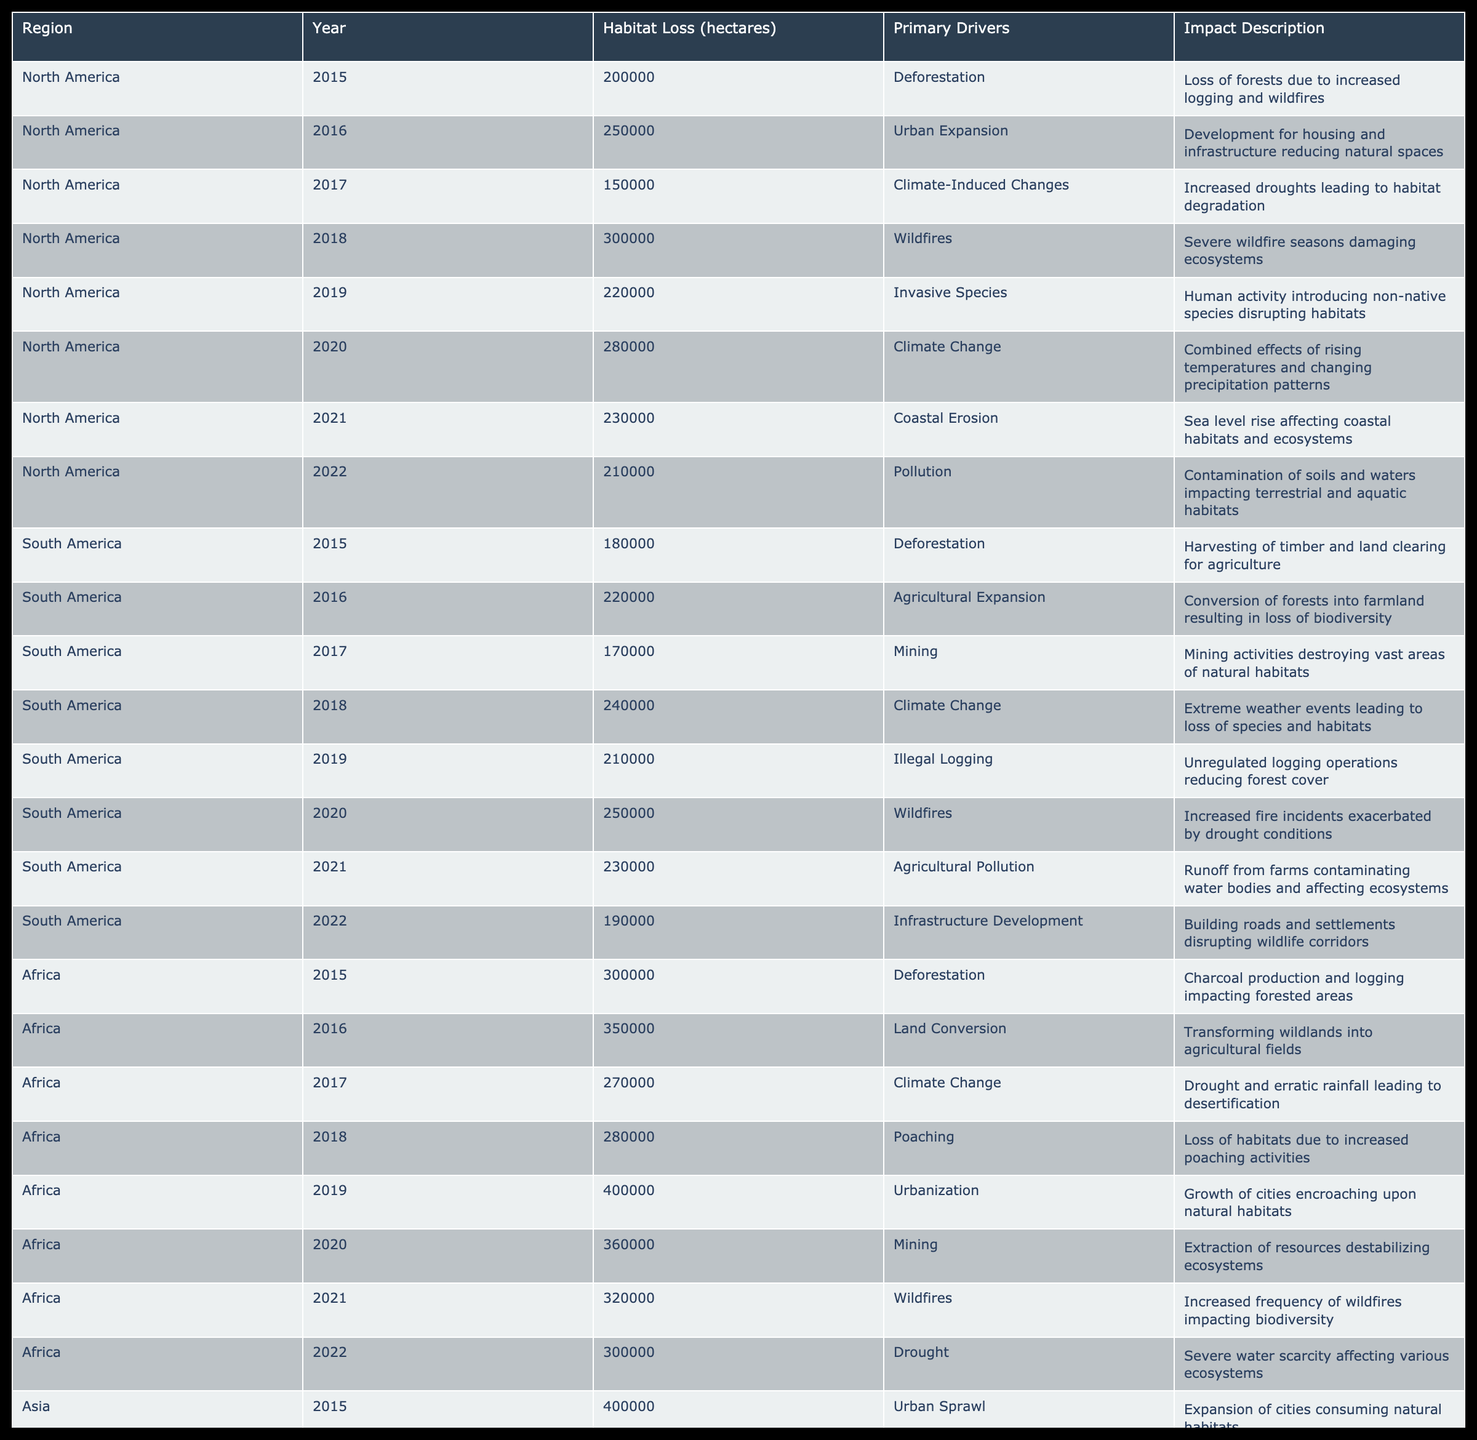What was the habitat loss in North America in 2019? Referring to the table, North America has a record of 220,000 hectares of habitat loss in the year 2019.
Answer: 220000 Which region experienced the highest habitat loss in 2020? Looking at the table, Africa had the highest habitat loss in 2020 with 360,000 hectares.
Answer: 360000 What was the total habitat loss for South America from 2015 to 2022? Summing up the habitat loss numbers: 180000 + 220000 + 170000 + 240000 + 210000 + 250000 + 230000 + 190000 = 1500000 hectares total for South America during those years.
Answer: 1500000 Did Asia show a decrease in habitat loss from 2015 to 2026? Reviewing the table indicates that Asia's habitat loss fluctuated from 400000 in 2015 to 440000 in 2022; therefore, there was an increase followed by a slight decrease. Thus, the statement is false.
Answer: No Which primary driver contributed to the most habitat loss in Africa in 2019? The table shows that in Africa, the primary driver for habitat loss in 2019 was urbanization, leading to 400,000 hectares of habitat loss.
Answer: Urbanization 